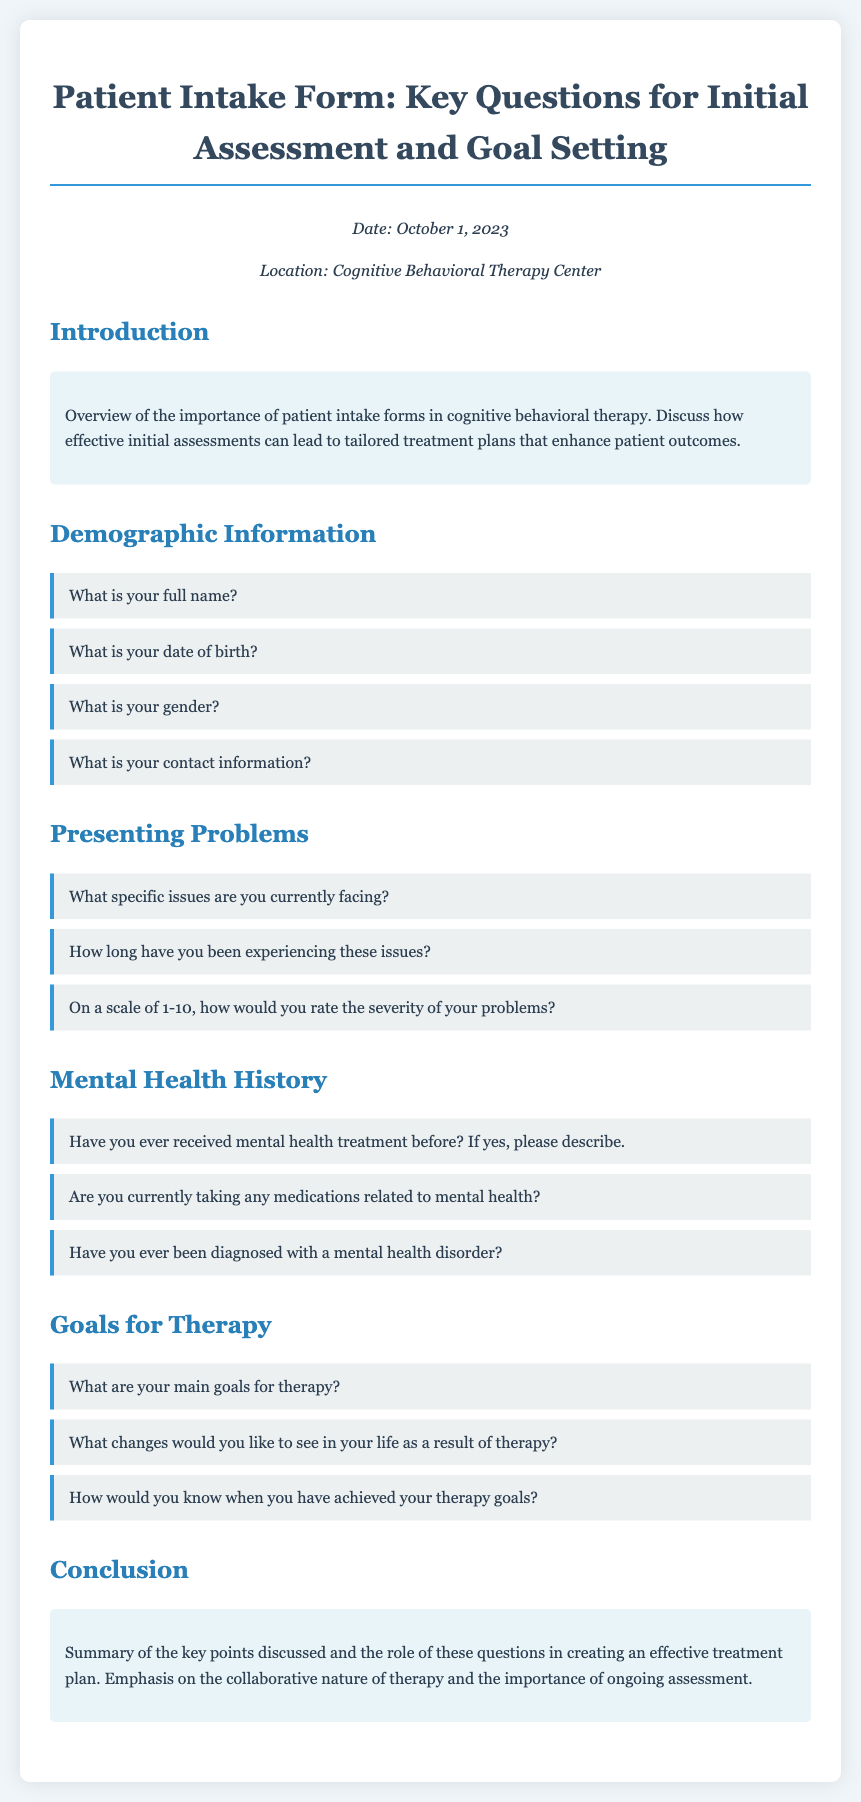What is the title of the document? The title is indicated at the top of the document and describes the content covered within, which is related to patient intake forms.
Answer: Patient Intake Form: Key Questions for Initial Assessment and Goal Setting What is the date of the document? The date is mentioned in the meta-info section, indicating when the document was created or updated.
Answer: October 1, 2023 What section discusses the importance of patient intake forms? The introduction section provides an overview of the importance of patient intake forms in cognitive behavioral therapy.
Answer: Introduction What is included in the demographic information section? The demographic information section contains specific questions aimed at understanding the patient's background, such as name and date of birth.
Answer: Name, date of birth, gender, contact information What specific issues are clients currently facing according to the presenting problems section? This section contains questions focused on the presenting issues of clients, which is essential for assessment.
Answer: Specific issues What do clients need to describe in the mental health history section? Clients are asked about their previous mental health treatment and diagnoses to understand their background better.
Answer: Mental health treatment and diagnoses What are clients encouraged to identify for therapy goals? Clients are prompted to specify their main goals for therapy as a guide for the treatment process.
Answer: Main goals for therapy How would clients recognize the achievement of their therapy goals? The section on goals for therapy asks for indicators that signify progress and achievement, which is crucial for therapy evaluation.
Answer: Indicators of achievement 